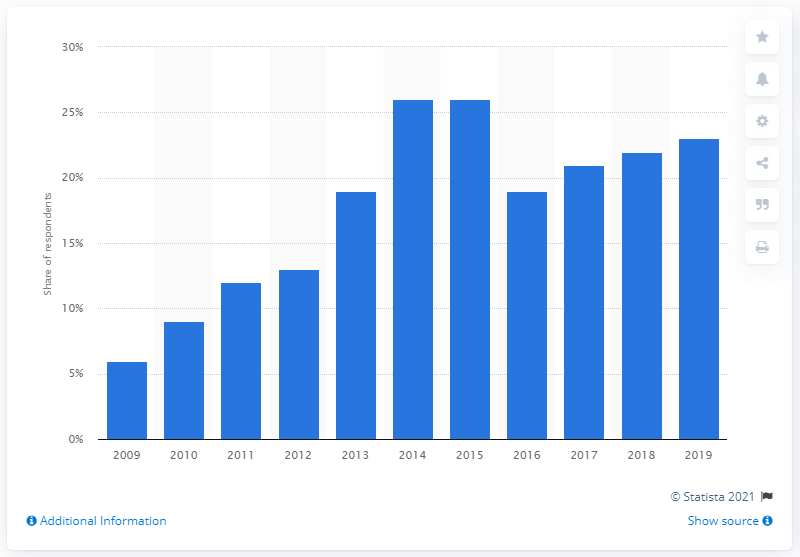Mention a couple of crucial points in this snapshot. According to a survey conducted in 2019, 23% of respondents reported using mobile phones or smartphones for gaming. In 2015, 26% of respondents reported using mobile phones or smartphones for gaming purposes. In 2009, 26% of respondents reported using mobile phones or smartphones for gaming. 